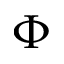Convert formula to latex. <formula><loc_0><loc_0><loc_500><loc_500>\Phi</formula> 